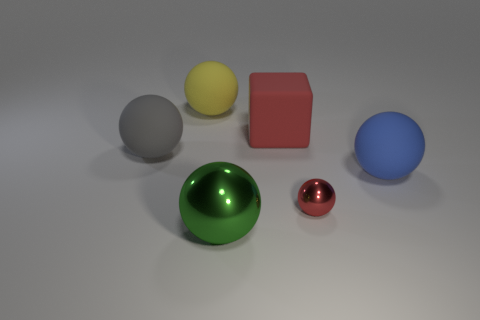Subtract all yellow balls. How many balls are left? 4 Subtract all green metal spheres. How many spheres are left? 4 Subtract all purple spheres. Subtract all purple cylinders. How many spheres are left? 5 Add 1 big matte blocks. How many objects exist? 7 Subtract all blocks. How many objects are left? 5 Add 5 yellow spheres. How many yellow spheres are left? 6 Add 3 brown balls. How many brown balls exist? 3 Subtract 0 purple cylinders. How many objects are left? 6 Subtract all tiny green metal cubes. Subtract all big green metallic balls. How many objects are left? 5 